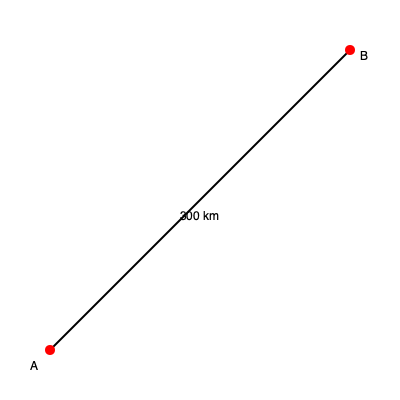As a reporter investigating helicopter safety, you need to estimate the fuel requirements for a flight between two locations. On the map above, points A and B represent the departure and arrival locations, respectively. The straight-line distance between these points is 300 km. If the helicopter consumes 0.5 liters of fuel per kilometer and requires an additional 20% fuel reserve for safety, how many liters of fuel should be loaded for this flight? To calculate the required fuel for the helicopter flight, we'll follow these steps:

1. Calculate the base fuel requirement:
   - Distance = 300 km
   - Fuel consumption = 0.5 liters/km
   - Base fuel = Distance × Fuel consumption
   - Base fuel = 300 km × 0.5 liters/km = 150 liters

2. Calculate the safety reserve (20% of base fuel):
   - Safety reserve = Base fuel × 20%
   - Safety reserve = 150 liters × 0.20 = 30 liters

3. Calculate the total fuel requirement:
   - Total fuel = Base fuel + Safety reserve
   - Total fuel = 150 liters + 30 liters = 180 liters

Therefore, the helicopter should be loaded with 180 liters of fuel for this flight, ensuring enough fuel for the journey plus a 20% safety reserve.
Answer: 180 liters 